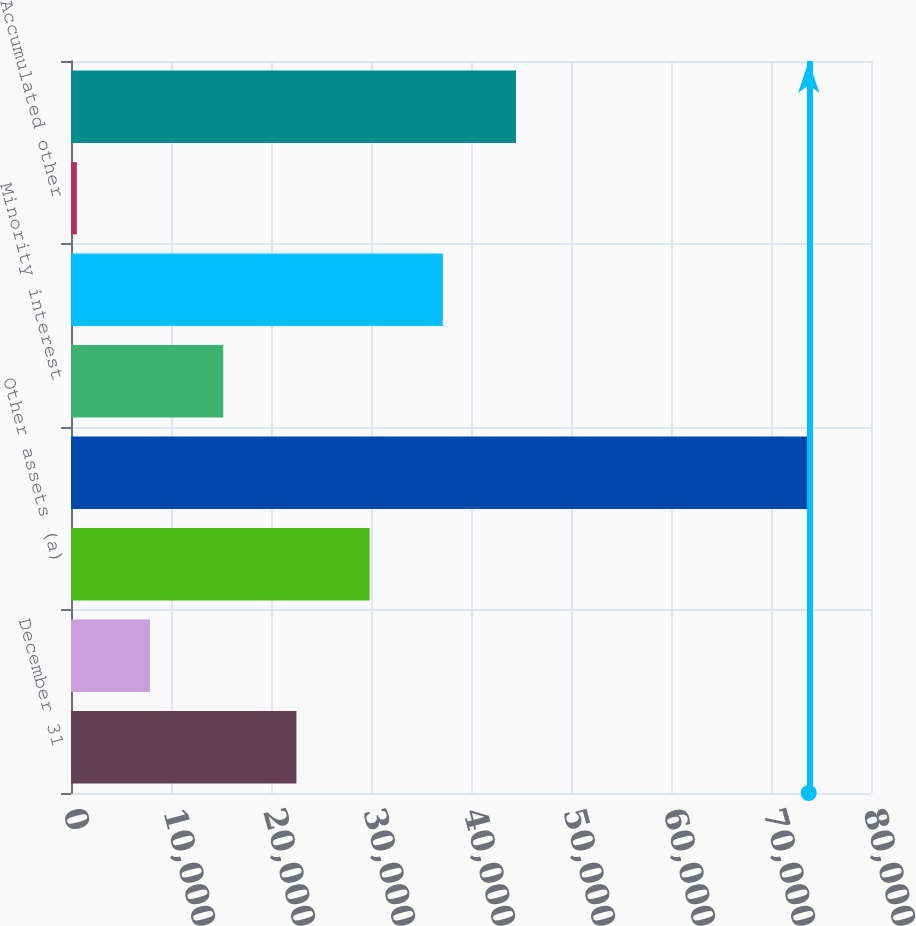<chart> <loc_0><loc_0><loc_500><loc_500><bar_chart><fcel>December 31<fcel>Deferred income taxes<fcel>Other assets (a)<fcel>Total assets (a)<fcel>Minority interest<fcel>Earnings retained in the<fcel>Accumulated other<fcel>Total shareholders' equity<nl><fcel>22542.5<fcel>7905.43<fcel>29861<fcel>73772.2<fcel>15224<fcel>37179.6<fcel>586.9<fcel>44498.1<nl></chart> 